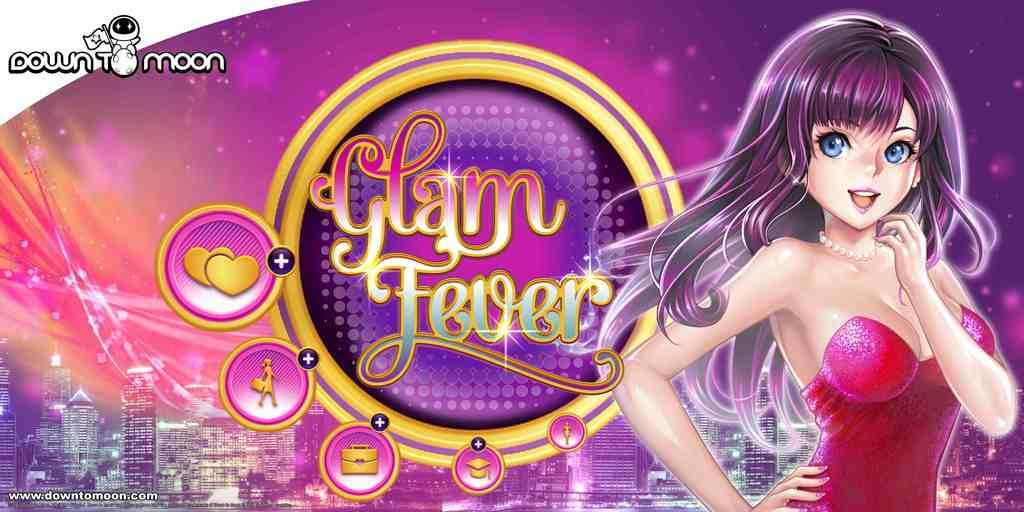What is featured on the poster in the image? The poster in the image has an image of a woman and images of buildings. Are there any words on the poster? Yes, there is text on the poster. What type of oven is shown in the image? There is no oven present in the image; it features a poster with an image of a woman and images of buildings. Can you see a patch on the woman's sock in the image? There is no woman wearing a sock in the image, as the image on the poster shows a woman without any visible clothing. 